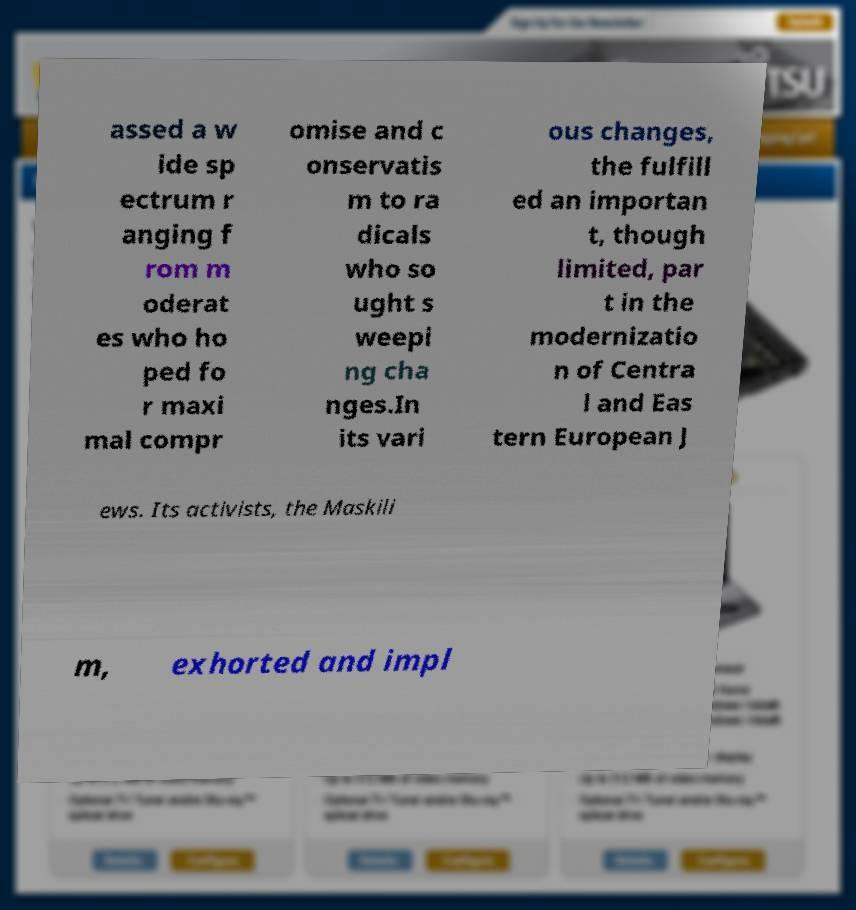For documentation purposes, I need the text within this image transcribed. Could you provide that? assed a w ide sp ectrum r anging f rom m oderat es who ho ped fo r maxi mal compr omise and c onservatis m to ra dicals who so ught s weepi ng cha nges.In its vari ous changes, the fulfill ed an importan t, though limited, par t in the modernizatio n of Centra l and Eas tern European J ews. Its activists, the Maskili m, exhorted and impl 